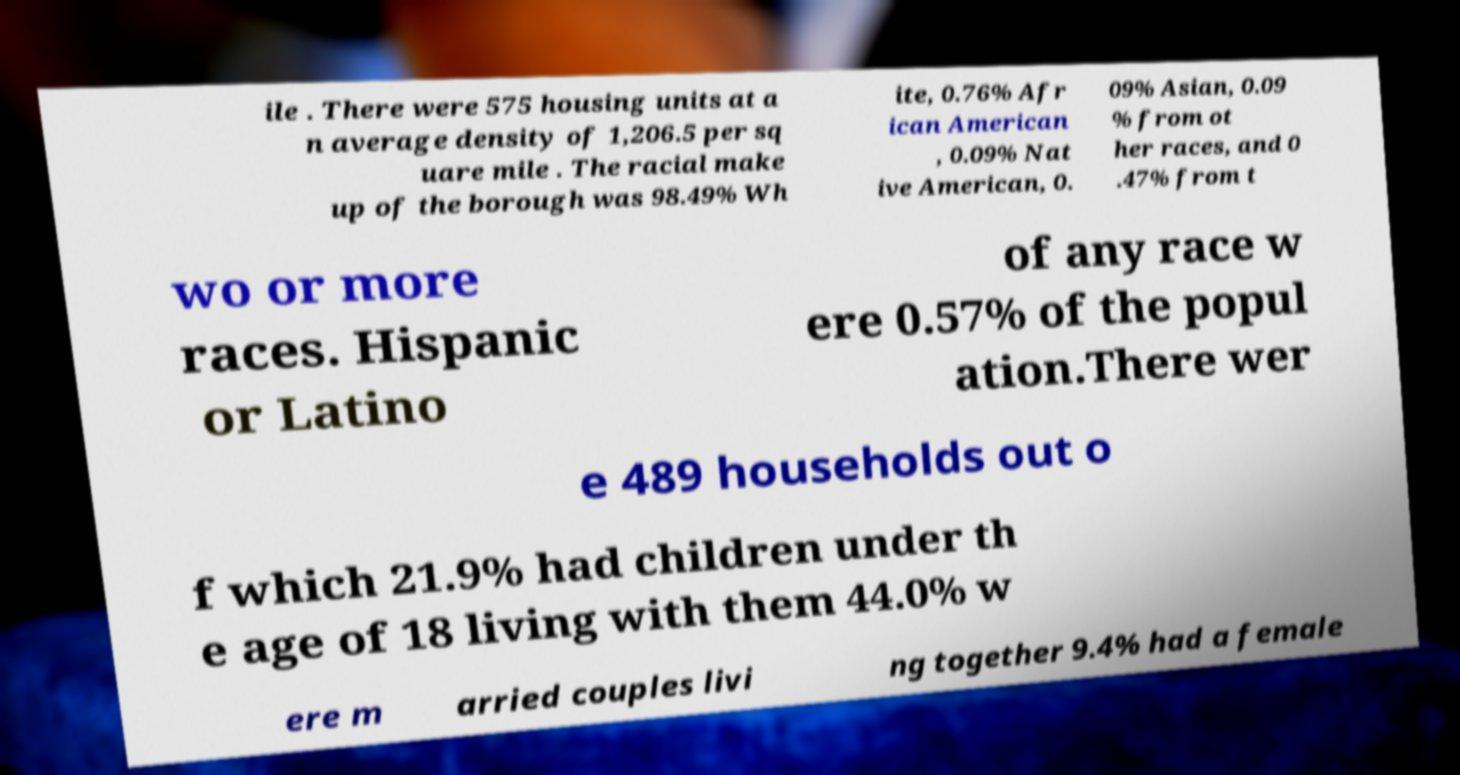There's text embedded in this image that I need extracted. Can you transcribe it verbatim? ile . There were 575 housing units at a n average density of 1,206.5 per sq uare mile . The racial make up of the borough was 98.49% Wh ite, 0.76% Afr ican American , 0.09% Nat ive American, 0. 09% Asian, 0.09 % from ot her races, and 0 .47% from t wo or more races. Hispanic or Latino of any race w ere 0.57% of the popul ation.There wer e 489 households out o f which 21.9% had children under th e age of 18 living with them 44.0% w ere m arried couples livi ng together 9.4% had a female 